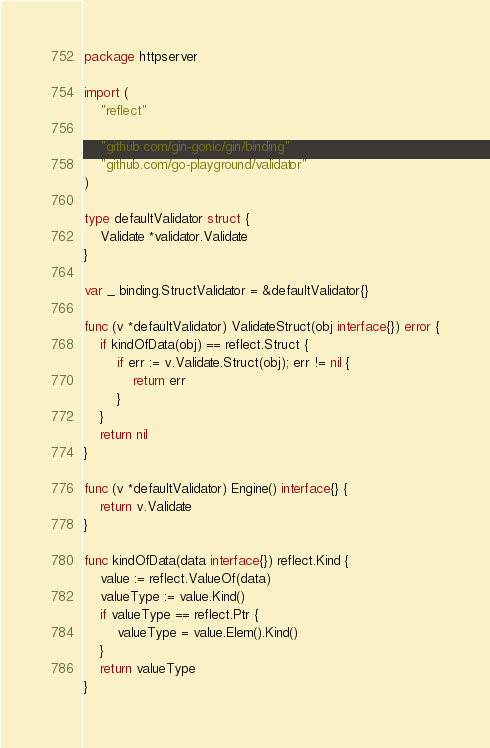Convert code to text. <code><loc_0><loc_0><loc_500><loc_500><_Go_>package httpserver

import (
	"reflect"

	"github.com/gin-gonic/gin/binding"
	"github.com/go-playground/validator"
)

type defaultValidator struct {
	Validate *validator.Validate
}

var _ binding.StructValidator = &defaultValidator{}

func (v *defaultValidator) ValidateStruct(obj interface{}) error {
	if kindOfData(obj) == reflect.Struct {
		if err := v.Validate.Struct(obj); err != nil {
			return err
		}
	}
	return nil
}

func (v *defaultValidator) Engine() interface{} {
	return v.Validate
}

func kindOfData(data interface{}) reflect.Kind {
	value := reflect.ValueOf(data)
	valueType := value.Kind()
	if valueType == reflect.Ptr {
		valueType = value.Elem().Kind()
	}
	return valueType
}
</code> 